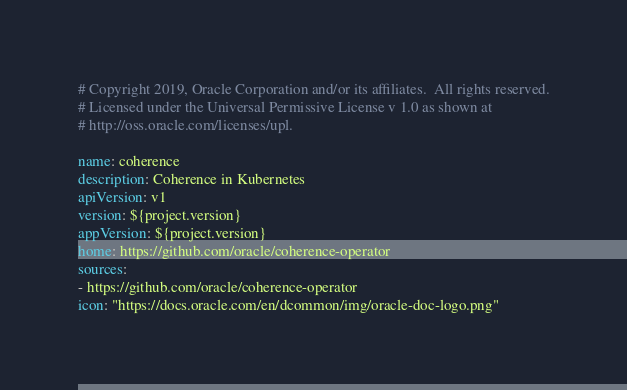Convert code to text. <code><loc_0><loc_0><loc_500><loc_500><_YAML_># Copyright 2019, Oracle Corporation and/or its affiliates.  All rights reserved.
# Licensed under the Universal Permissive License v 1.0 as shown at
# http://oss.oracle.com/licenses/upl.

name: coherence
description: Coherence in Kubernetes
apiVersion: v1
version: ${project.version}
appVersion: ${project.version}
home: https://github.com/oracle/coherence-operator
sources:
- https://github.com/oracle/coherence-operator
icon: "https://docs.oracle.com/en/dcommon/img/oracle-doc-logo.png"
</code> 